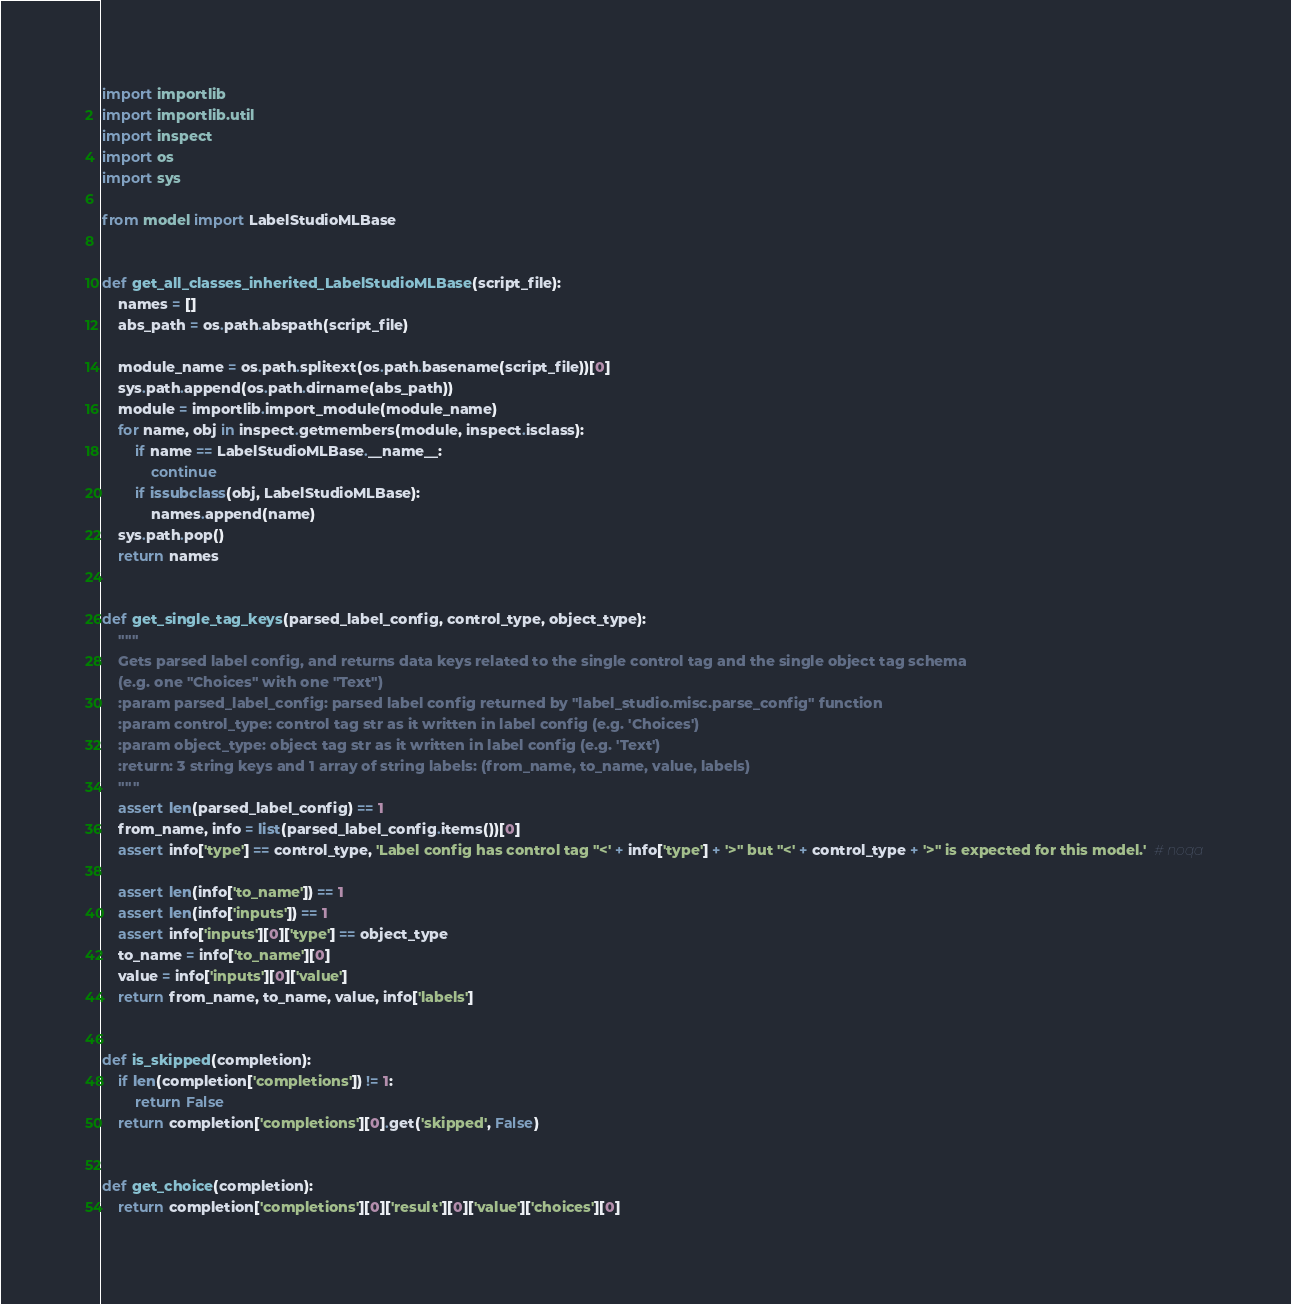<code> <loc_0><loc_0><loc_500><loc_500><_Python_>import importlib
import importlib.util
import inspect
import os
import sys

from model import LabelStudioMLBase


def get_all_classes_inherited_LabelStudioMLBase(script_file):
    names = []
    abs_path = os.path.abspath(script_file)
    
    module_name = os.path.splitext(os.path.basename(script_file))[0]
    sys.path.append(os.path.dirname(abs_path))
    module = importlib.import_module(module_name)
    for name, obj in inspect.getmembers(module, inspect.isclass):
        if name == LabelStudioMLBase.__name__:
            continue
        if issubclass(obj, LabelStudioMLBase):
            names.append(name)
    sys.path.pop()
    return names


def get_single_tag_keys(parsed_label_config, control_type, object_type):
    """
    Gets parsed label config, and returns data keys related to the single control tag and the single object tag schema
    (e.g. one "Choices" with one "Text")
    :param parsed_label_config: parsed label config returned by "label_studio.misc.parse_config" function
    :param control_type: control tag str as it written in label config (e.g. 'Choices')
    :param object_type: object tag str as it written in label config (e.g. 'Text')
    :return: 3 string keys and 1 array of string labels: (from_name, to_name, value, labels)
    """
    assert len(parsed_label_config) == 1
    from_name, info = list(parsed_label_config.items())[0]
    assert info['type'] == control_type, 'Label config has control tag "<' + info['type'] + '>" but "<' + control_type + '>" is expected for this model.'  # noqa

    assert len(info['to_name']) == 1
    assert len(info['inputs']) == 1
    assert info['inputs'][0]['type'] == object_type
    to_name = info['to_name'][0]
    value = info['inputs'][0]['value']
    return from_name, to_name, value, info['labels']


def is_skipped(completion):
    if len(completion['completions']) != 1:
        return False
    return completion['completions'][0].get('skipped', False)


def get_choice(completion):
    return completion['completions'][0]['result'][0]['value']['choices'][0]</code> 